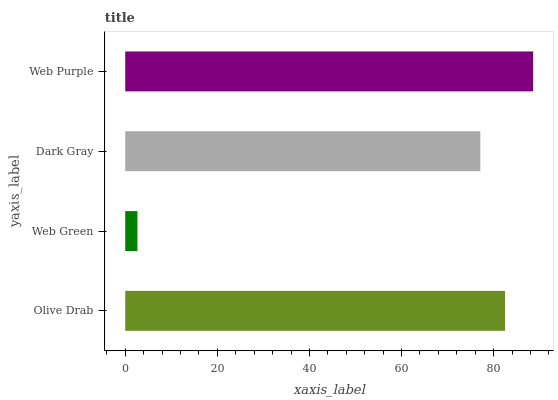Is Web Green the minimum?
Answer yes or no. Yes. Is Web Purple the maximum?
Answer yes or no. Yes. Is Dark Gray the minimum?
Answer yes or no. No. Is Dark Gray the maximum?
Answer yes or no. No. Is Dark Gray greater than Web Green?
Answer yes or no. Yes. Is Web Green less than Dark Gray?
Answer yes or no. Yes. Is Web Green greater than Dark Gray?
Answer yes or no. No. Is Dark Gray less than Web Green?
Answer yes or no. No. Is Olive Drab the high median?
Answer yes or no. Yes. Is Dark Gray the low median?
Answer yes or no. Yes. Is Dark Gray the high median?
Answer yes or no. No. Is Olive Drab the low median?
Answer yes or no. No. 